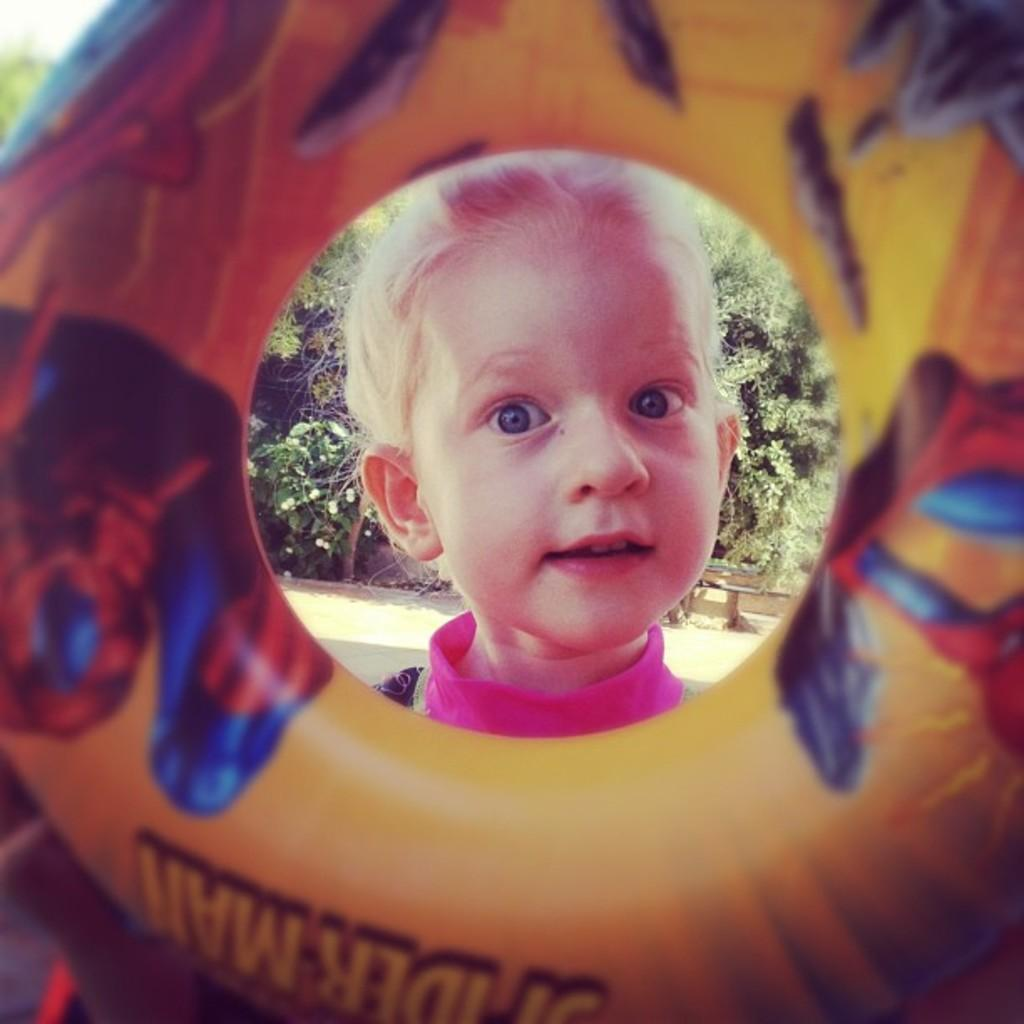What object can be seen in the image? There is a tube in the image. Can you describe the person in the image? A person's face is visible in the image. What can be seen in the background of the image? There are trees in the background of the image. What type of fowl can be seen flying near the trees in the image? There is no fowl visible in the image; only a tube, a person's face, and trees are present. 